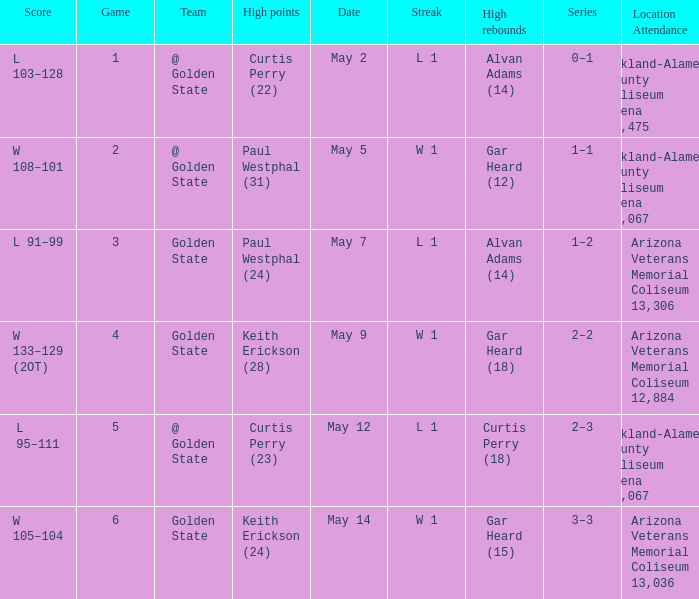How many games had they won or lost in a row on May 9? W 1. 